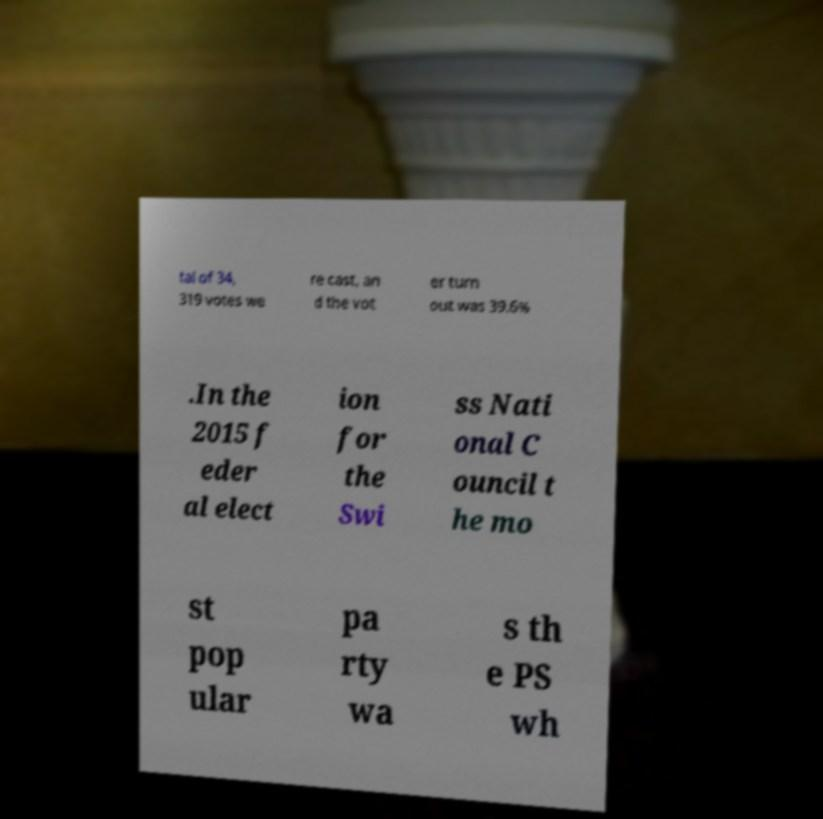I need the written content from this picture converted into text. Can you do that? tal of 34, 319 votes we re cast, an d the vot er turn out was 39.6% .In the 2015 f eder al elect ion for the Swi ss Nati onal C ouncil t he mo st pop ular pa rty wa s th e PS wh 